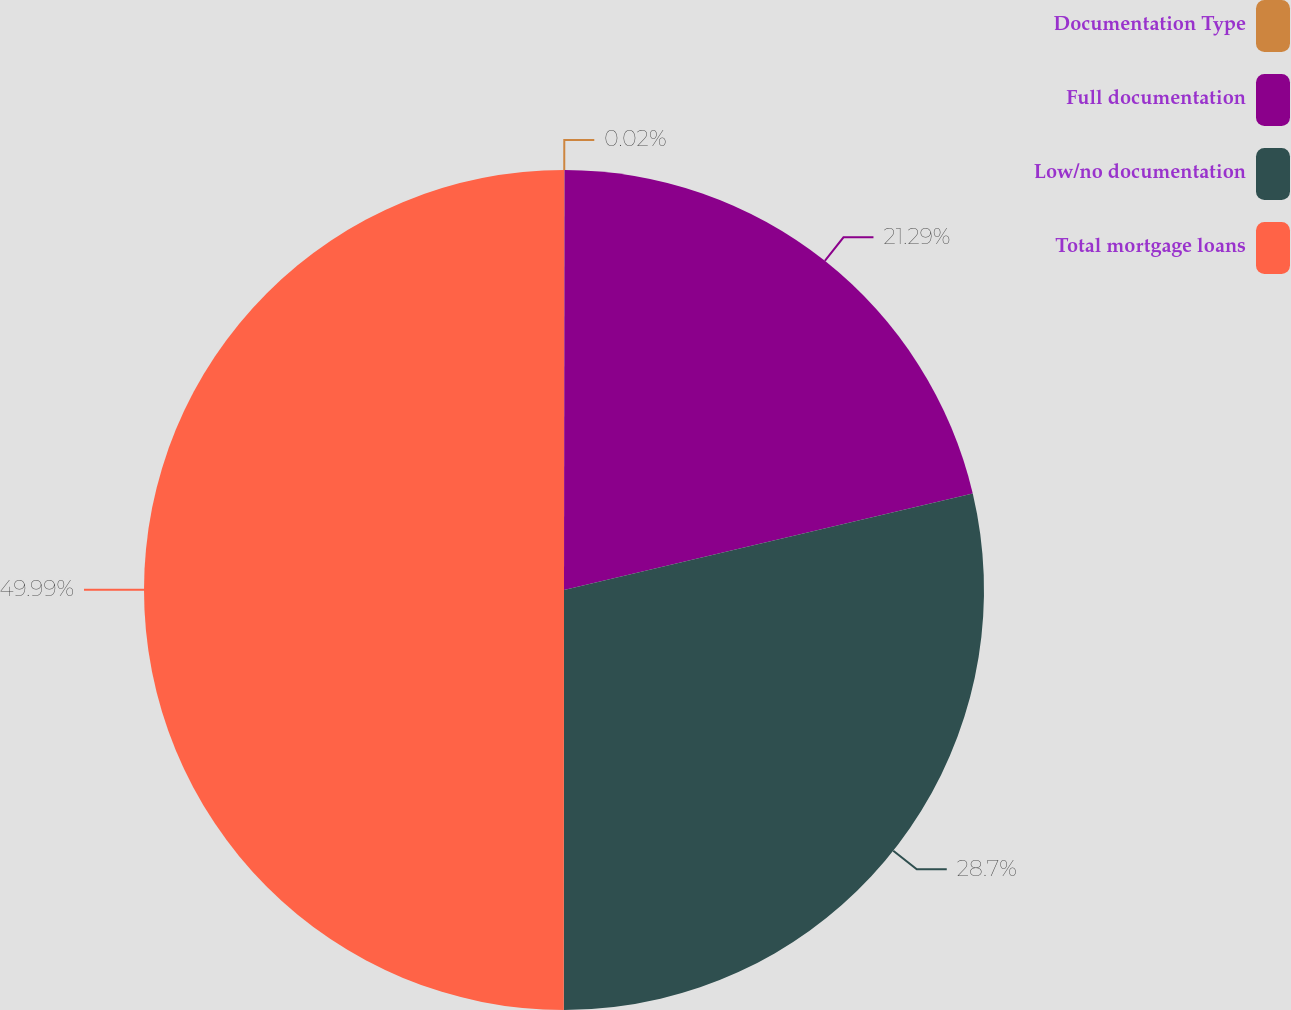<chart> <loc_0><loc_0><loc_500><loc_500><pie_chart><fcel>Documentation Type<fcel>Full documentation<fcel>Low/no documentation<fcel>Total mortgage loans<nl><fcel>0.02%<fcel>21.29%<fcel>28.7%<fcel>49.99%<nl></chart> 